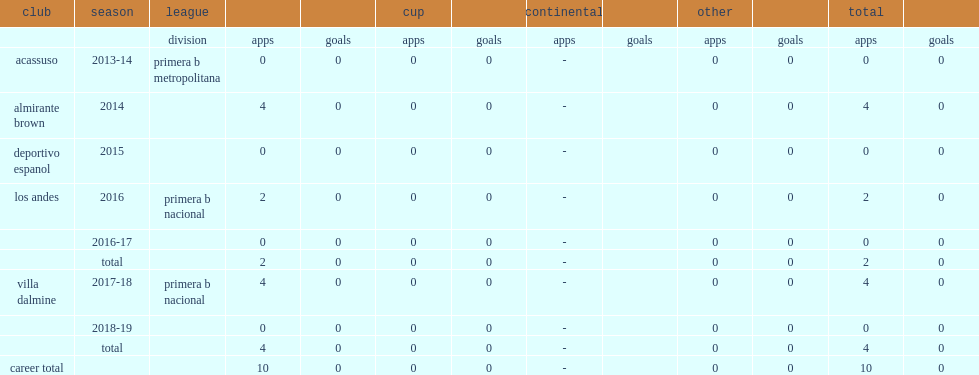Which club did marcelo tinari play for in 2016? Los andes. 